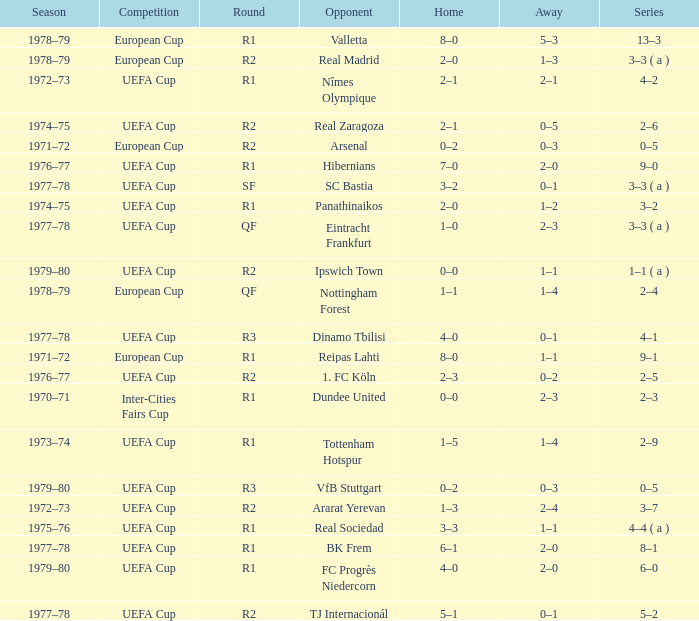Which Home has a Round of r1, and an Opponent of dundee united? 0–0. 